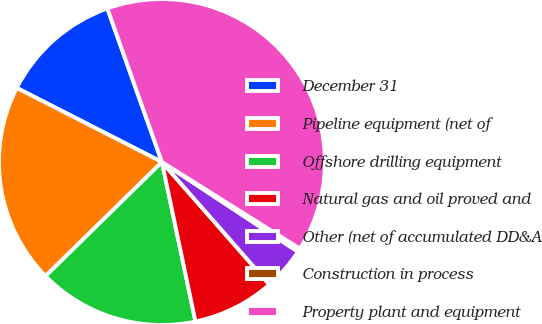Convert chart. <chart><loc_0><loc_0><loc_500><loc_500><pie_chart><fcel>December 31<fcel>Pipeline equipment (net of<fcel>Offshore drilling equipment<fcel>Natural gas and oil proved and<fcel>Other (net of accumulated DD&A<fcel>Construction in process<fcel>Property plant and equipment<nl><fcel>12.06%<fcel>19.86%<fcel>15.96%<fcel>8.16%<fcel>4.26%<fcel>0.36%<fcel>39.36%<nl></chart> 